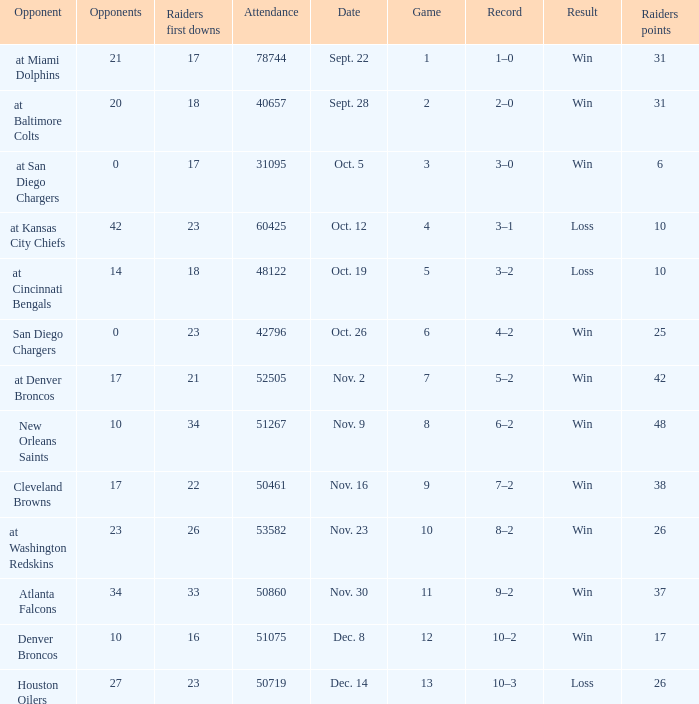Give me the full table as a dictionary. {'header': ['Opponent', 'Opponents', 'Raiders first downs', 'Attendance', 'Date', 'Game', 'Record', 'Result', 'Raiders points'], 'rows': [['at Miami Dolphins', '21', '17', '78744', 'Sept. 22', '1', '1–0', 'Win', '31'], ['at Baltimore Colts', '20', '18', '40657', 'Sept. 28', '2', '2–0', 'Win', '31'], ['at San Diego Chargers', '0', '17', '31095', 'Oct. 5', '3', '3–0', 'Win', '6'], ['at Kansas City Chiefs', '42', '23', '60425', 'Oct. 12', '4', '3–1', 'Loss', '10'], ['at Cincinnati Bengals', '14', '18', '48122', 'Oct. 19', '5', '3–2', 'Loss', '10'], ['San Diego Chargers', '0', '23', '42796', 'Oct. 26', '6', '4–2', 'Win', '25'], ['at Denver Broncos', '17', '21', '52505', 'Nov. 2', '7', '5–2', 'Win', '42'], ['New Orleans Saints', '10', '34', '51267', 'Nov. 9', '8', '6–2', 'Win', '48'], ['Cleveland Browns', '17', '22', '50461', 'Nov. 16', '9', '7–2', 'Win', '38'], ['at Washington Redskins', '23', '26', '53582', 'Nov. 23', '10', '8–2', 'Win', '26'], ['Atlanta Falcons', '34', '33', '50860', 'Nov. 30', '11', '9–2', 'Win', '37'], ['Denver Broncos', '10', '16', '51075', 'Dec. 8', '12', '10–2', 'Win', '17'], ['Houston Oilers', '27', '23', '50719', 'Dec. 14', '13', '10–3', 'Loss', '26']]} What was the result of the game seen by 31095 people? Win. 